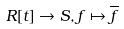<formula> <loc_0><loc_0><loc_500><loc_500>R [ t ] \rightarrow S , f \mapsto \overline { f }</formula> 